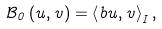<formula> <loc_0><loc_0><loc_500><loc_500>{ \mathcal { B } } _ { 0 } \left ( u , v \right ) = \left \langle b u , v \right \rangle _ { I } ,</formula> 